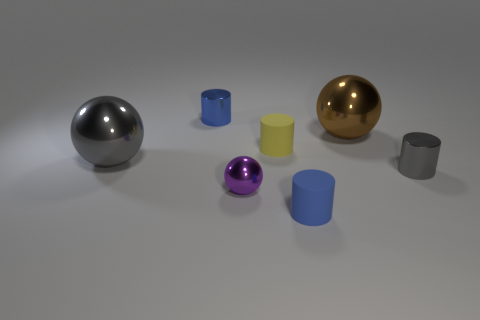Is there a purple thing? yes 